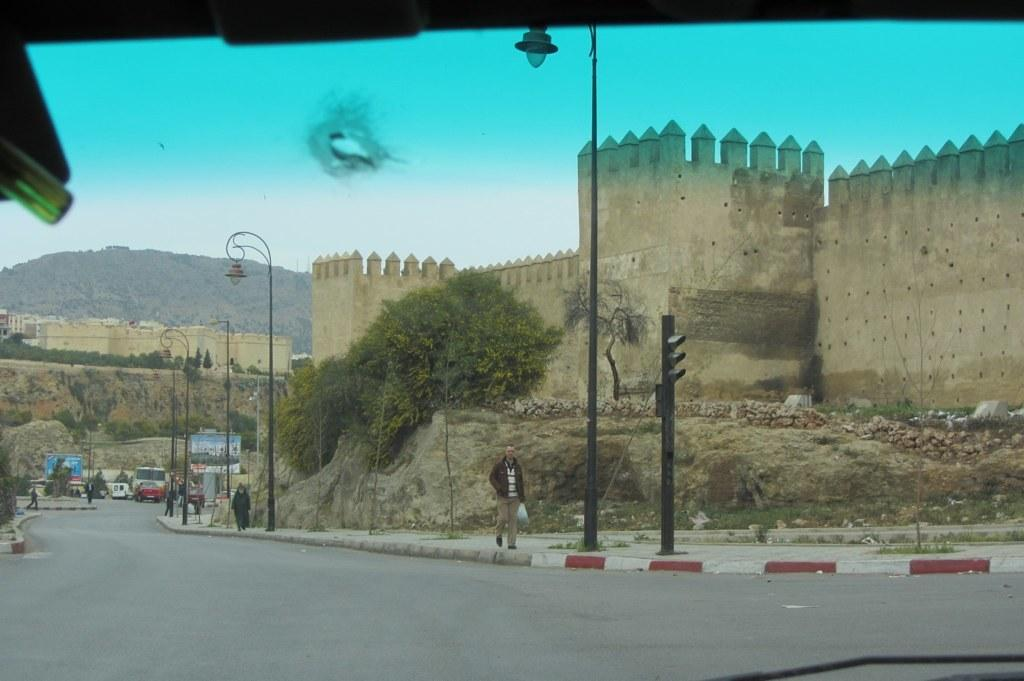What is the main subject of the image? The main subject of the image is a man. What is the man doing in the image? The man is walking in the image. What is the man holding while walking? The man is holding a bag in the image. What can be seen in the background of the image? There are trees, buildings, traffic lights, poles, and other vehicles on the road in the background of the image. Where is the meeting taking place in the image? There is no meeting taking place in the image; it only shows a man walking while holding a bag. What type of boats can be seen in the image? There are no boats present in the image. 